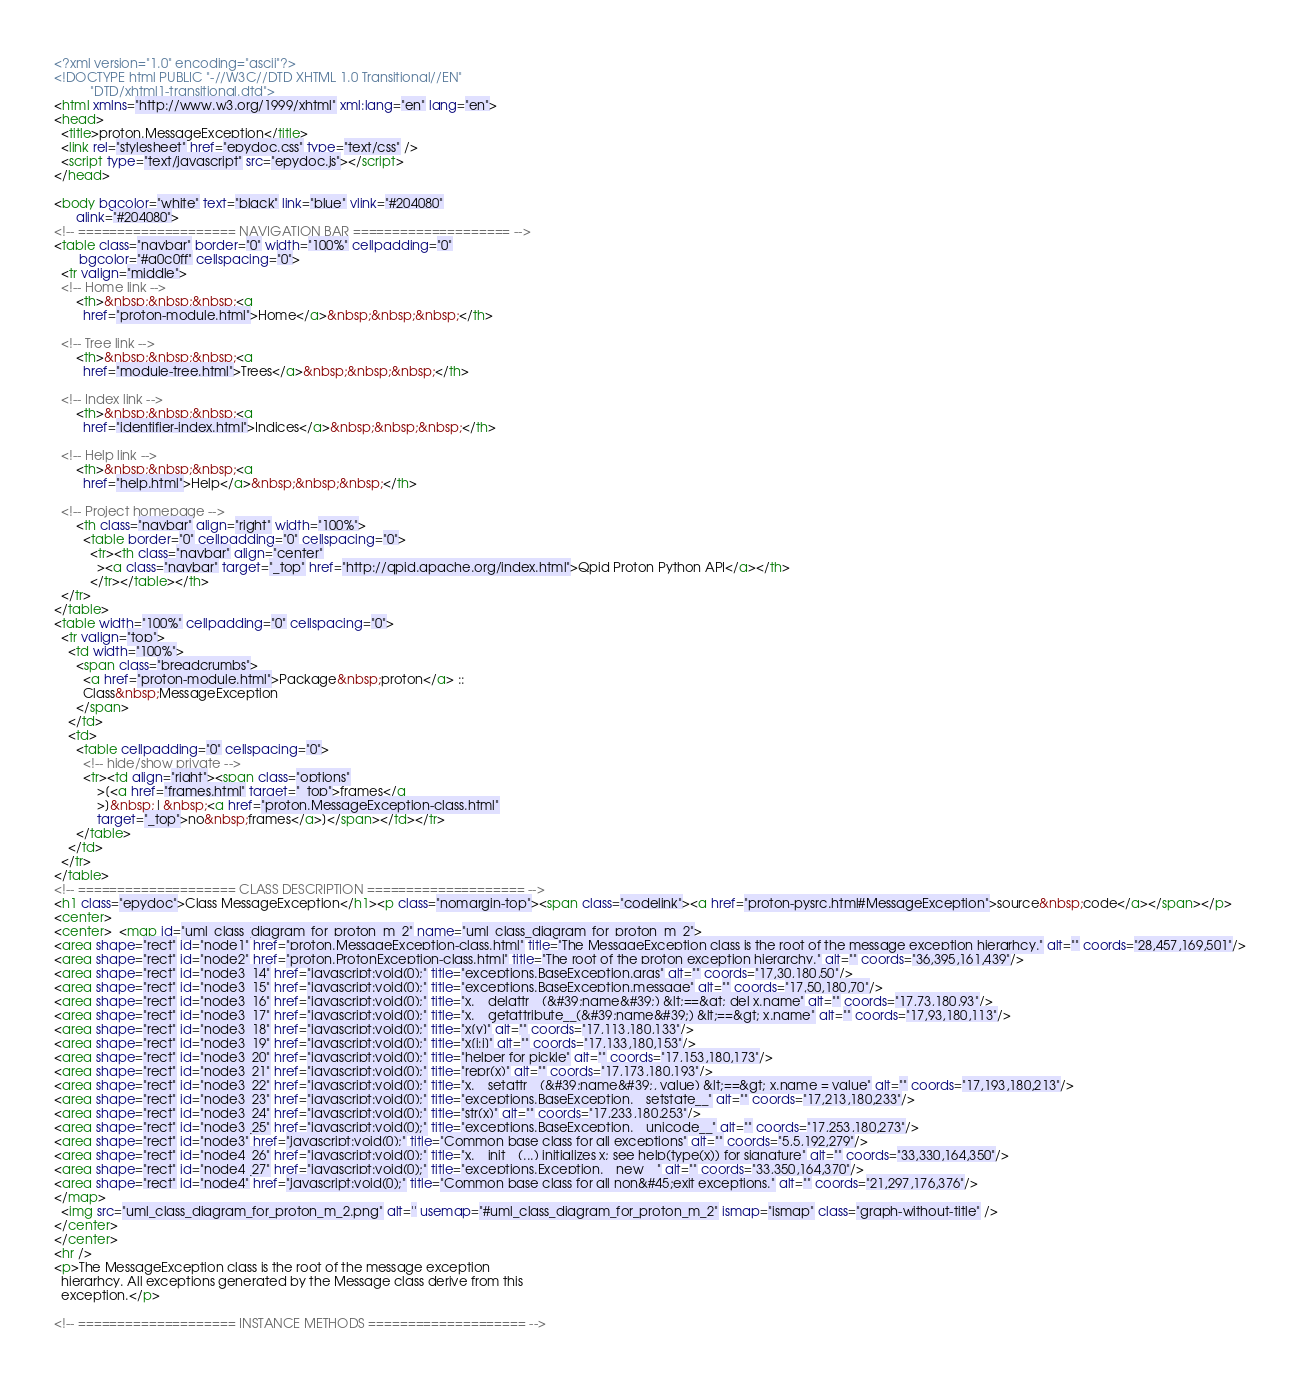<code> <loc_0><loc_0><loc_500><loc_500><_HTML_><?xml version="1.0" encoding="ascii"?>
<!DOCTYPE html PUBLIC "-//W3C//DTD XHTML 1.0 Transitional//EN"
          "DTD/xhtml1-transitional.dtd">
<html xmlns="http://www.w3.org/1999/xhtml" xml:lang="en" lang="en">
<head>
  <title>proton.MessageException</title>
  <link rel="stylesheet" href="epydoc.css" type="text/css" />
  <script type="text/javascript" src="epydoc.js"></script>
</head>

<body bgcolor="white" text="black" link="blue" vlink="#204080"
      alink="#204080">
<!-- ==================== NAVIGATION BAR ==================== -->
<table class="navbar" border="0" width="100%" cellpadding="0"
       bgcolor="#a0c0ff" cellspacing="0">
  <tr valign="middle">
  <!-- Home link -->
      <th>&nbsp;&nbsp;&nbsp;<a
        href="proton-module.html">Home</a>&nbsp;&nbsp;&nbsp;</th>

  <!-- Tree link -->
      <th>&nbsp;&nbsp;&nbsp;<a
        href="module-tree.html">Trees</a>&nbsp;&nbsp;&nbsp;</th>

  <!-- Index link -->
      <th>&nbsp;&nbsp;&nbsp;<a
        href="identifier-index.html">Indices</a>&nbsp;&nbsp;&nbsp;</th>

  <!-- Help link -->
      <th>&nbsp;&nbsp;&nbsp;<a
        href="help.html">Help</a>&nbsp;&nbsp;&nbsp;</th>

  <!-- Project homepage -->
      <th class="navbar" align="right" width="100%">
        <table border="0" cellpadding="0" cellspacing="0">
          <tr><th class="navbar" align="center"
            ><a class="navbar" target="_top" href="http://qpid.apache.org/index.html">Qpid Proton Python API</a></th>
          </tr></table></th>
  </tr>
</table>
<table width="100%" cellpadding="0" cellspacing="0">
  <tr valign="top">
    <td width="100%">
      <span class="breadcrumbs">
        <a href="proton-module.html">Package&nbsp;proton</a> ::
        Class&nbsp;MessageException
      </span>
    </td>
    <td>
      <table cellpadding="0" cellspacing="0">
        <!-- hide/show private -->
        <tr><td align="right"><span class="options"
            >[<a href="frames.html" target="_top">frames</a
            >]&nbsp;|&nbsp;<a href="proton.MessageException-class.html"
            target="_top">no&nbsp;frames</a>]</span></td></tr>
      </table>
    </td>
  </tr>
</table>
<!-- ==================== CLASS DESCRIPTION ==================== -->
<h1 class="epydoc">Class MessageException</h1><p class="nomargin-top"><span class="codelink"><a href="proton-pysrc.html#MessageException">source&nbsp;code</a></span></p>
<center>
<center>  <map id="uml_class_diagram_for_proton_m_2" name="uml_class_diagram_for_proton_m_2">
<area shape="rect" id="node1" href="proton.MessageException-class.html" title="The MessageException class is the root of the message exception hierarhcy." alt="" coords="28,457,169,501"/>
<area shape="rect" id="node2" href="proton.ProtonException-class.html" title="The root of the proton exception hierarchy." alt="" coords="36,395,161,439"/>
<area shape="rect" id="node3_14" href="javascript:void(0);" title="exceptions.BaseException.args" alt="" coords="17,30,180,50"/>
<area shape="rect" id="node3_15" href="javascript:void(0);" title="exceptions.BaseException.message" alt="" coords="17,50,180,70"/>
<area shape="rect" id="node3_16" href="javascript:void(0);" title="x.__delattr__(&#39;name&#39;) &lt;==&gt; del x.name" alt="" coords="17,73,180,93"/>
<area shape="rect" id="node3_17" href="javascript:void(0);" title="x.__getattribute__(&#39;name&#39;) &lt;==&gt; x.name" alt="" coords="17,93,180,113"/>
<area shape="rect" id="node3_18" href="javascript:void(0);" title="x[y]" alt="" coords="17,113,180,133"/>
<area shape="rect" id="node3_19" href="javascript:void(0);" title="x[i:j]" alt="" coords="17,133,180,153"/>
<area shape="rect" id="node3_20" href="javascript:void(0);" title="helper for pickle" alt="" coords="17,153,180,173"/>
<area shape="rect" id="node3_21" href="javascript:void(0);" title="repr(x)" alt="" coords="17,173,180,193"/>
<area shape="rect" id="node3_22" href="javascript:void(0);" title="x.__setattr__(&#39;name&#39;, value) &lt;==&gt; x.name = value" alt="" coords="17,193,180,213"/>
<area shape="rect" id="node3_23" href="javascript:void(0);" title="exceptions.BaseException.__setstate__" alt="" coords="17,213,180,233"/>
<area shape="rect" id="node3_24" href="javascript:void(0);" title="str(x)" alt="" coords="17,233,180,253"/>
<area shape="rect" id="node3_25" href="javascript:void(0);" title="exceptions.BaseException.__unicode__" alt="" coords="17,253,180,273"/>
<area shape="rect" id="node3" href="javascript:void(0);" title="Common base class for all exceptions" alt="" coords="5,5,192,279"/>
<area shape="rect" id="node4_26" href="javascript:void(0);" title="x.__init__(...) initializes x; see help(type(x)) for signature" alt="" coords="33,330,164,350"/>
<area shape="rect" id="node4_27" href="javascript:void(0);" title="exceptions.Exception.__new__" alt="" coords="33,350,164,370"/>
<area shape="rect" id="node4" href="javascript:void(0);" title="Common base class for all non&#45;exit exceptions." alt="" coords="21,297,176,376"/>
</map>
  <img src="uml_class_diagram_for_proton_m_2.png" alt='' usemap="#uml_class_diagram_for_proton_m_2" ismap="ismap" class="graph-without-title" />
</center>
</center>
<hr />
<p>The MessageException class is the root of the message exception 
  hierarhcy. All exceptions generated by the Message class derive from this
  exception.</p>

<!-- ==================== INSTANCE METHODS ==================== --></code> 